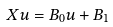<formula> <loc_0><loc_0><loc_500><loc_500>X u = B _ { 0 } u + B _ { 1 }</formula> 